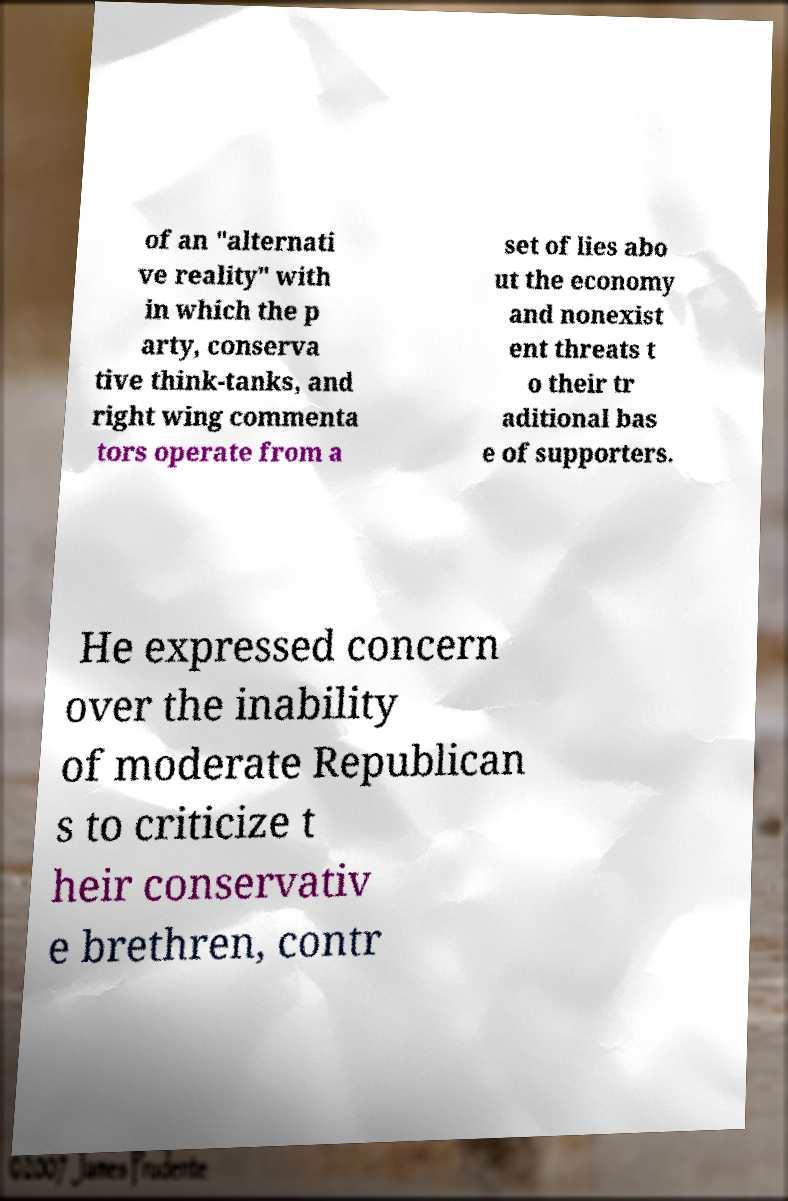For documentation purposes, I need the text within this image transcribed. Could you provide that? of an "alternati ve reality" with in which the p arty, conserva tive think-tanks, and right wing commenta tors operate from a set of lies abo ut the economy and nonexist ent threats t o their tr aditional bas e of supporters. He expressed concern over the inability of moderate Republican s to criticize t heir conservativ e brethren, contr 